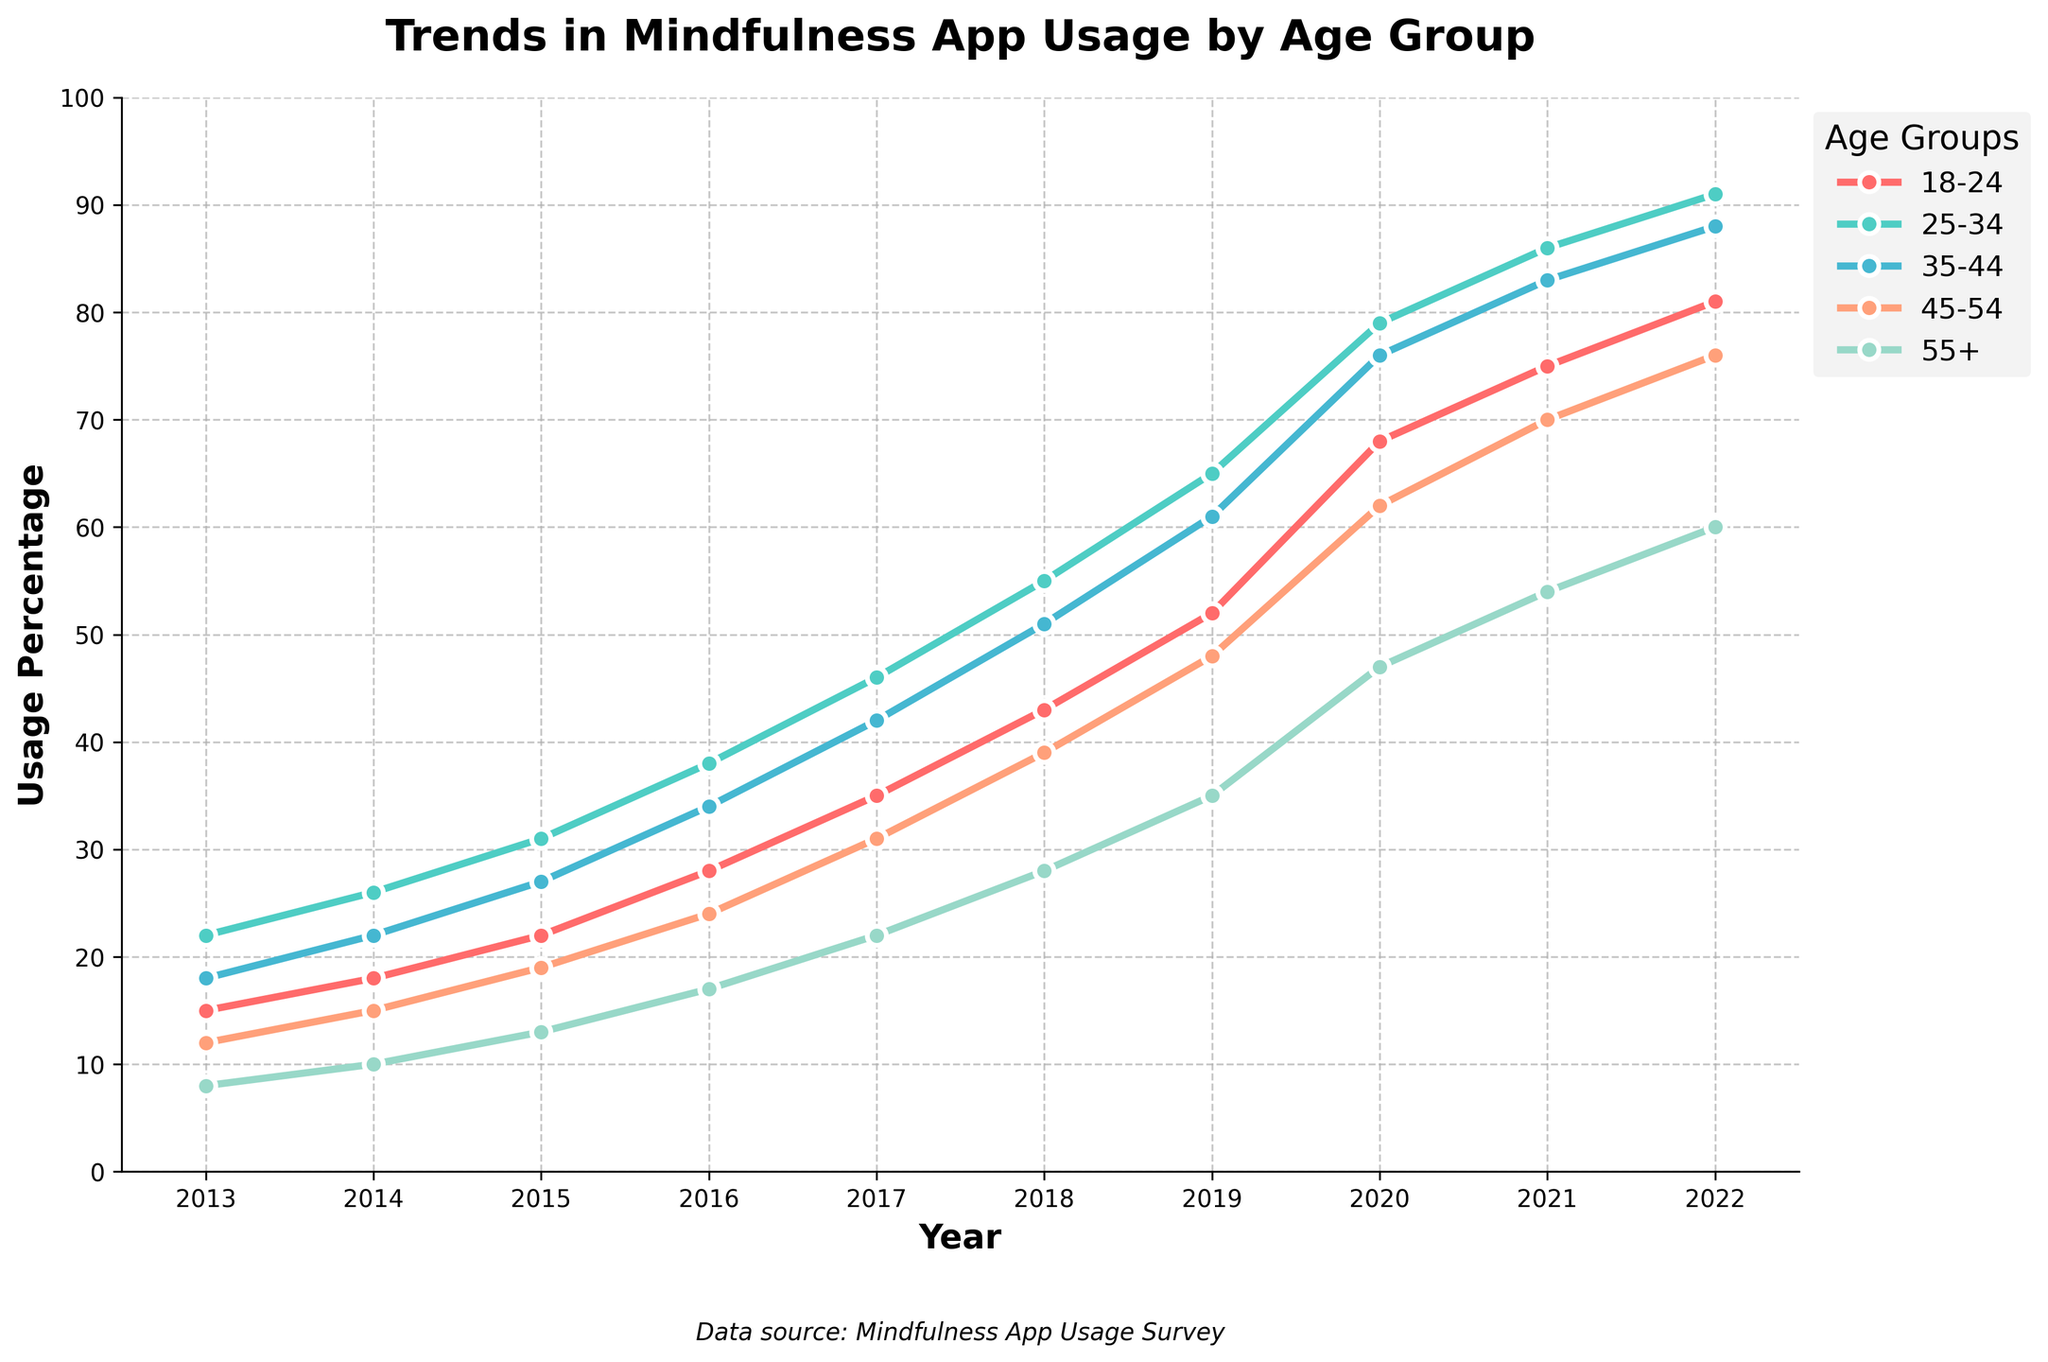What's the trend in mindfulness app usage for the 18-24 age group over the past decade? The trend for the 18-24 age group shows a consistent increase from 15% in 2013 to 81% in 2022, indicating a growing interest in mindfulness apps among younger users.
Answer: Increased from 15% to 81% Which age group had the highest increase in usage from 2013 to 2022? By comparing the values from 2013 to 2022 for each age group: 18-24 increased by 66%, 25-34 by 69%, 35-44 by 70%, 45-54 by 64%, and 55+ by 52%. The 35-44 age group had the highest increase.
Answer: 35-44 In 2020, which age group had a mindfulness app usage percentage greater than 60%? In 2020, the age groups 18-24 (68%), 25-34 (79%), 35-44 (76%), and 45-54 (62%) all had usage percentages greater than 60%. Only the 55+ group did not exceed 60%.
Answer: 18-24, 25-34, 35-44, 45-54 What is the difference in mindfulness app usage between the 25-34 and 55+ age groups in 2022? In 2022, the usage for the 25-34 age group is 91% and for the 55+ age group is 60%. The difference is 91% - 60% = 31%.
Answer: 31% Which age group showed the least growth in mindfulness app usage from 2013 to 2022? By comparing the increase from 2013 to 2022: 18-24 increased by 66%, 25-34 by 69%, 35-44 by 70%, 45-54 by 64%, and 55+ by 52%. The 55+ age group showed the least growth.
Answer: 55+ In which year did the 18-24 age group's usage surpass the 50% mark? The 18-24 age group's usage surpassed the 50% mark in 2019 with 52% usage.
Answer: 2019 What is the average usage percentage for the 45-54 age group from 2013 to 2022? Sum the percentages for 45-54 from 2013 to 2022: 12 + 15 + 19 + 24 + 31 + 39 + 48 + 62 + 70 + 76 = 396. The average is 396 / 10 = 39.6%
Answer: 39.6% By how much did the 35-44 age group's usage increase between 2016 and 2019? In 2016, the usage was 34% and in 2019 it was 61%. The increase is 61% - 34% = 27%.
Answer: 27% Which age group consistently has a higher usage increase every year compared to the previous year? By checking each age group year by year, the 35-44 age group consistently shows an increase each year from 2013 to 2022.
Answer: 35-44 In 2021, did any age group have less than 50% usage? By looking at the usage percentages in 2021: 18-24 (75%), 25-34 (86%), 35-44 (83%), 45-54 (70%), and 55+ (54%), none of the age groups had less than 50% usage.
Answer: No 